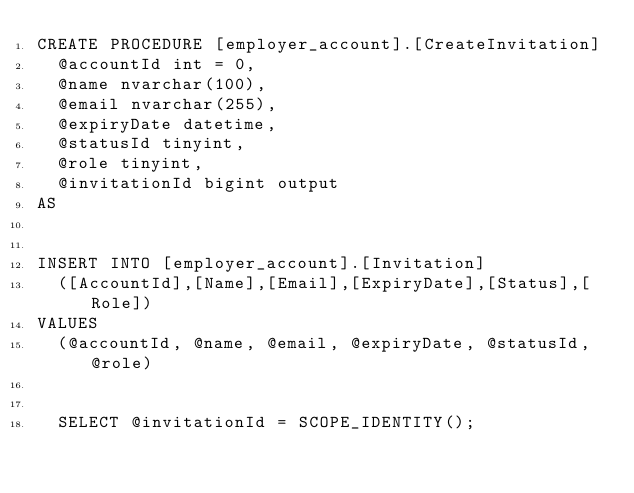Convert code to text. <code><loc_0><loc_0><loc_500><loc_500><_SQL_>CREATE PROCEDURE [employer_account].[CreateInvitation]
	@accountId int = 0,
	@name nvarchar(100),
	@email nvarchar(255),
	@expiryDate datetime,
	@statusId tinyint,
	@role tinyint,
	@invitationId bigint output
AS


INSERT INTO [employer_account].[Invitation] 
	([AccountId],[Name],[Email],[ExpiryDate],[Status],[Role]) 
VALUES 
	(@accountId, @name, @email, @expiryDate, @statusId, @role)


	SELECT @invitationId = SCOPE_IDENTITY();</code> 